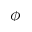<formula> <loc_0><loc_0><loc_500><loc_500>\phi</formula> 